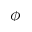<formula> <loc_0><loc_0><loc_500><loc_500>\phi</formula> 